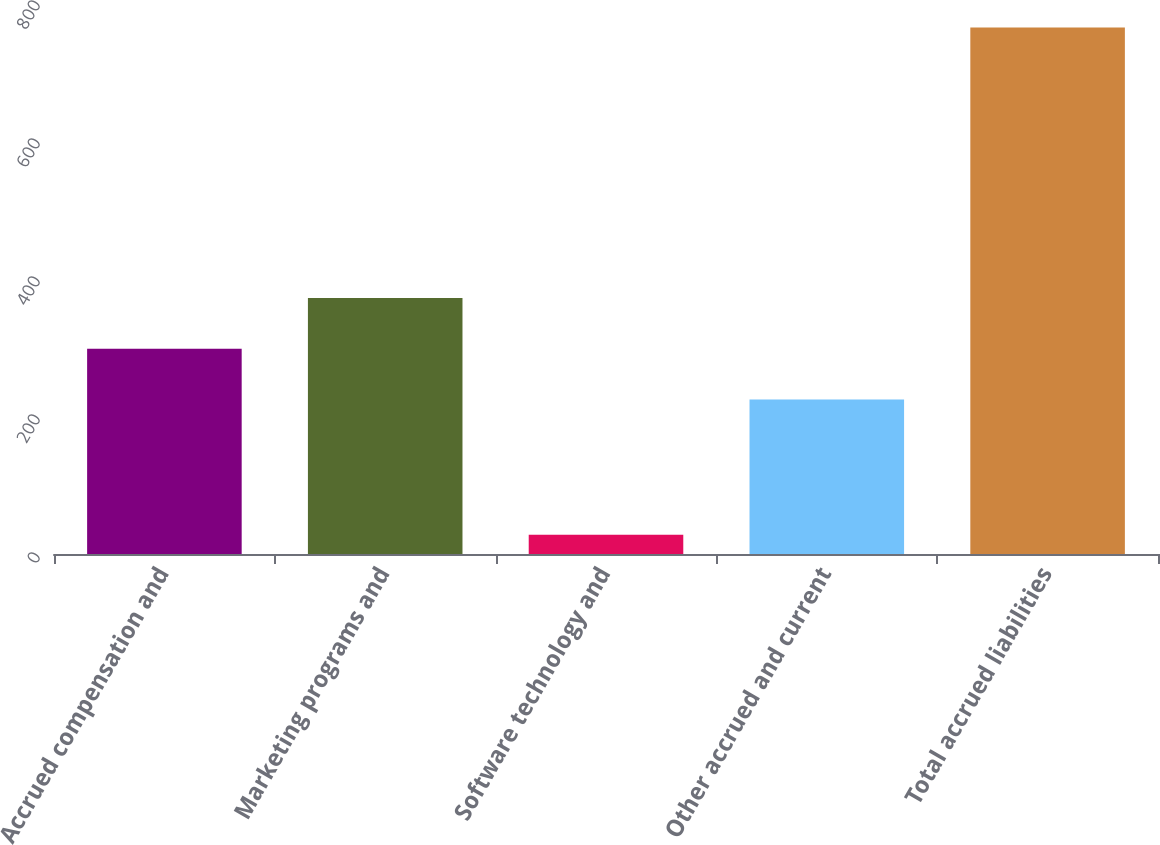Convert chart. <chart><loc_0><loc_0><loc_500><loc_500><bar_chart><fcel>Accrued compensation and<fcel>Marketing programs and<fcel>Software technology and<fcel>Other accrued and current<fcel>Total accrued liabilities<nl><fcel>297.5<fcel>371<fcel>28<fcel>224<fcel>763<nl></chart> 